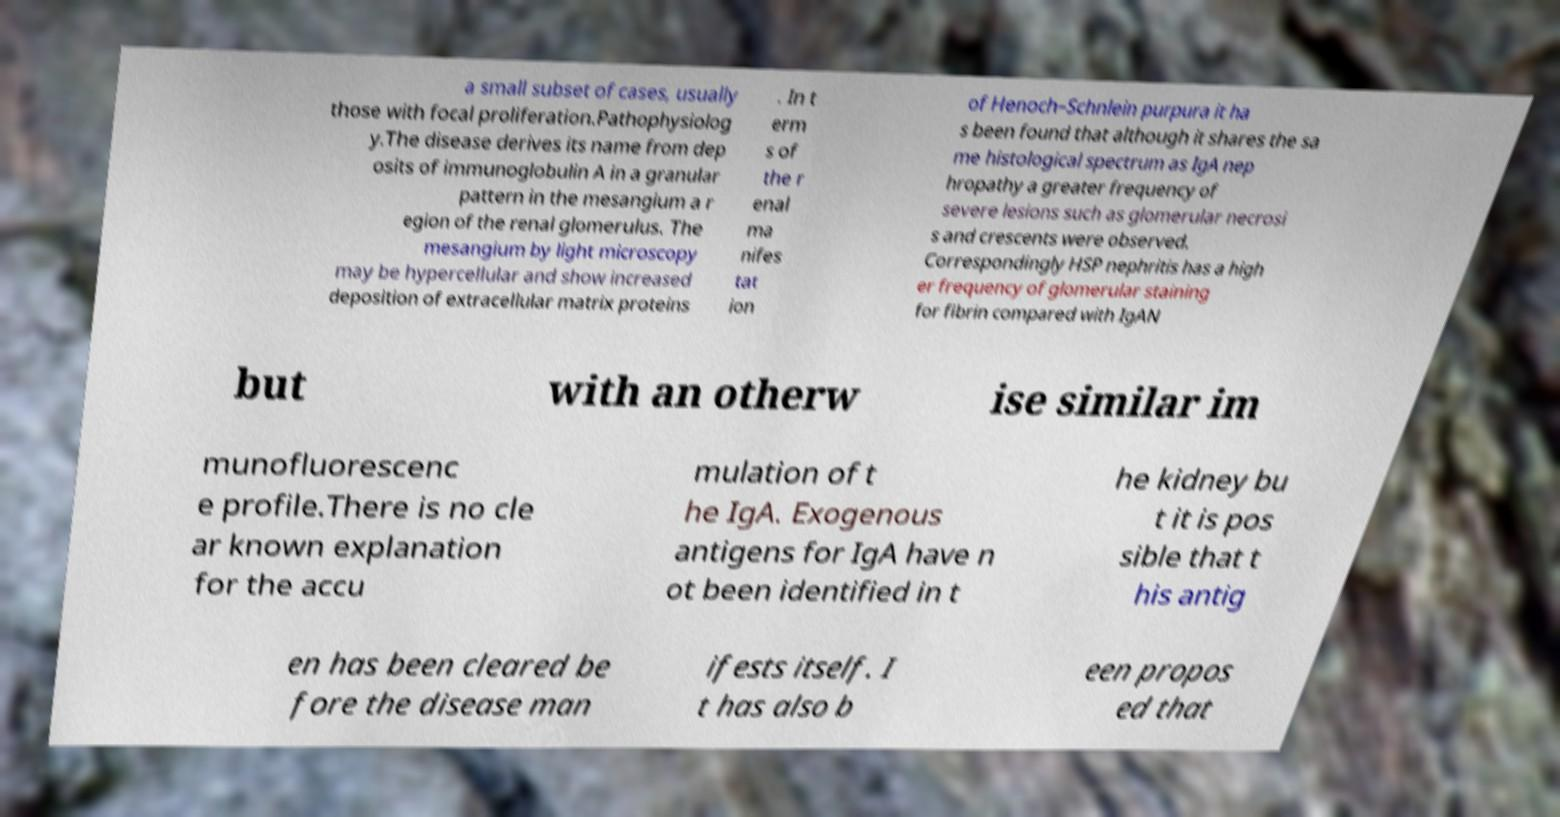Could you extract and type out the text from this image? a small subset of cases, usually those with focal proliferation.Pathophysiolog y.The disease derives its name from dep osits of immunoglobulin A in a granular pattern in the mesangium a r egion of the renal glomerulus. The mesangium by light microscopy may be hypercellular and show increased deposition of extracellular matrix proteins . In t erm s of the r enal ma nifes tat ion of Henoch–Schnlein purpura it ha s been found that although it shares the sa me histological spectrum as IgA nep hropathy a greater frequency of severe lesions such as glomerular necrosi s and crescents were observed. Correspondingly HSP nephritis has a high er frequency of glomerular staining for fibrin compared with IgAN but with an otherw ise similar im munofluorescenc e profile.There is no cle ar known explanation for the accu mulation of t he IgA. Exogenous antigens for IgA have n ot been identified in t he kidney bu t it is pos sible that t his antig en has been cleared be fore the disease man ifests itself. I t has also b een propos ed that 